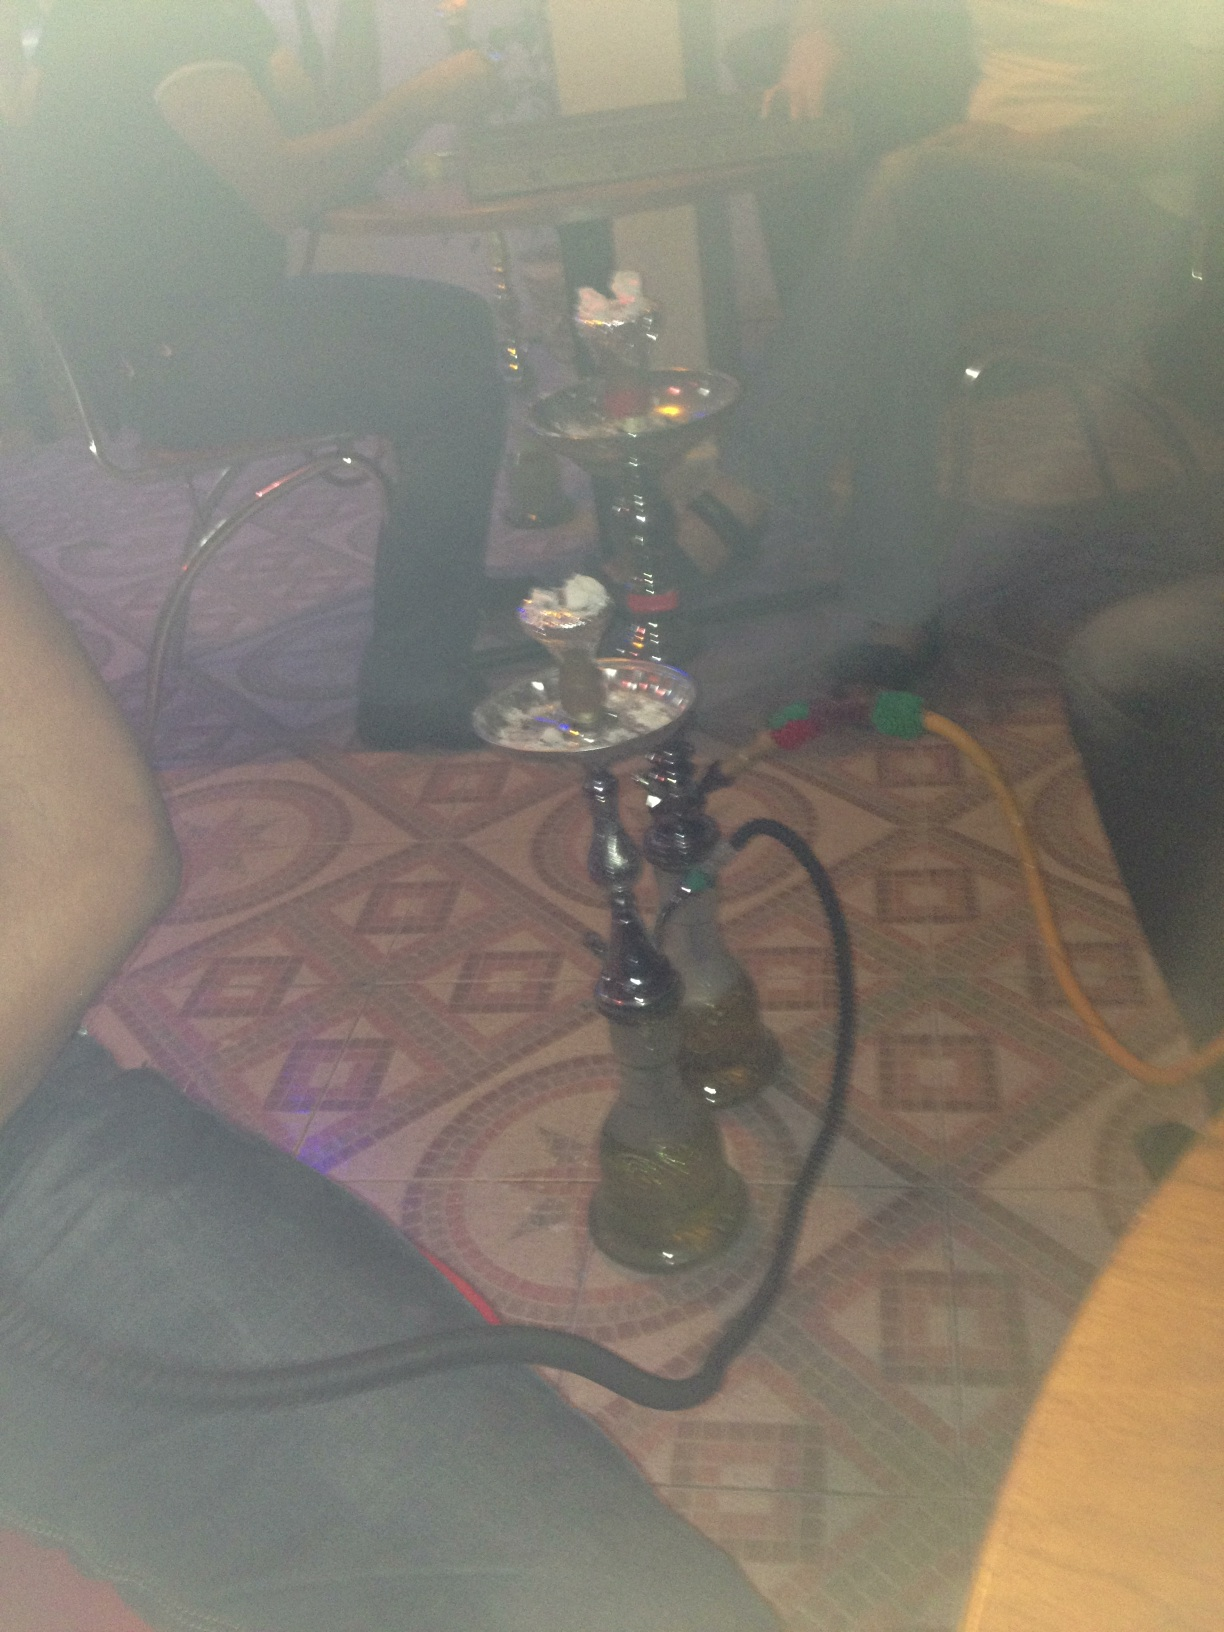What this? What this? from Vizwiz The item in the image is a hookah, also known as a shisha or water pipe, commonly used for smoking flavored tobacco. It consists of a base, which is partially filled with water, a shaft that rises up from the base, a bowl at the top for the tobacco, and one or more hoses with mouthpieces for inhaling the smoke. 